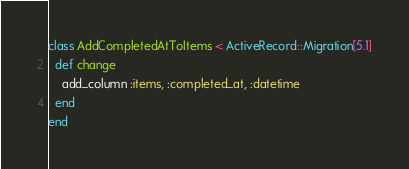<code> <loc_0><loc_0><loc_500><loc_500><_Ruby_>class AddCompletedAtToItems < ActiveRecord::Migration[5.1]
  def change
    add_column :items, :completed_at, :datetime
  end
end
</code> 